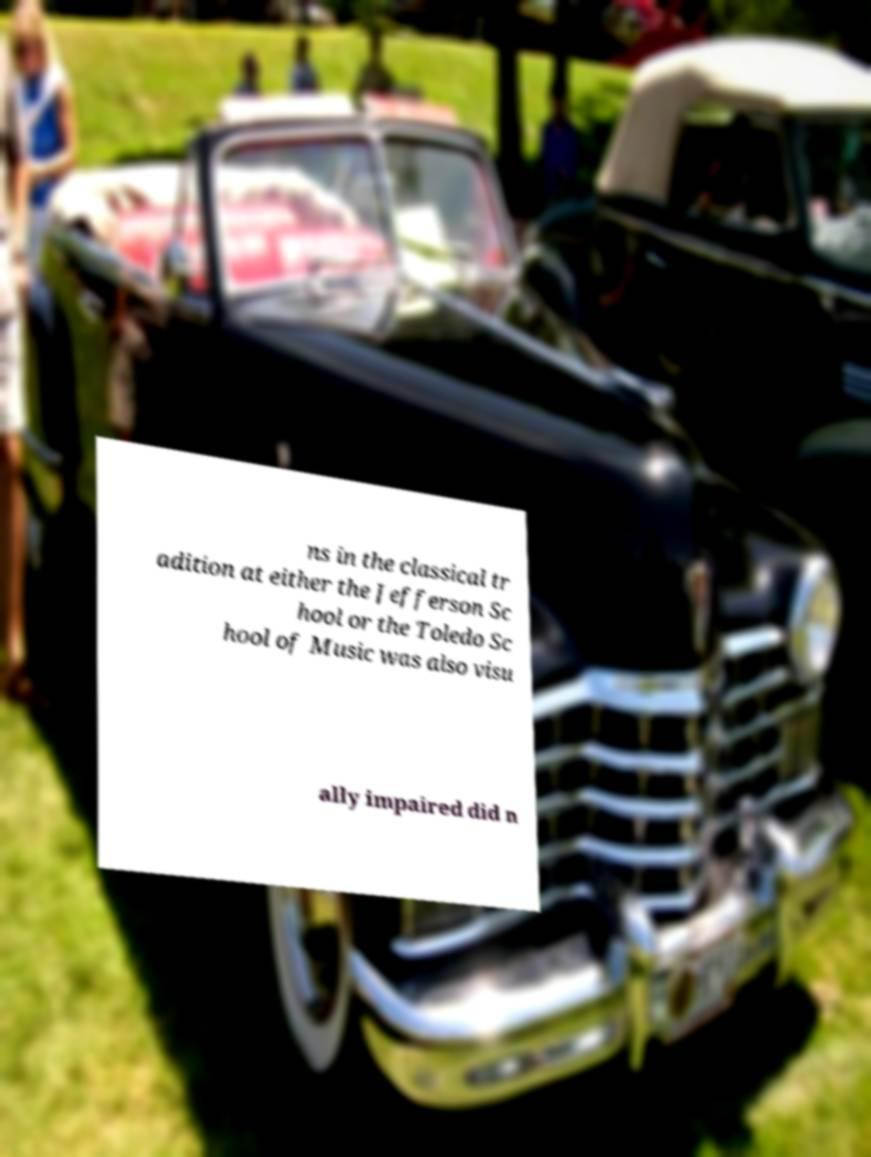Can you accurately transcribe the text from the provided image for me? ns in the classical tr adition at either the Jefferson Sc hool or the Toledo Sc hool of Music was also visu ally impaired did n 